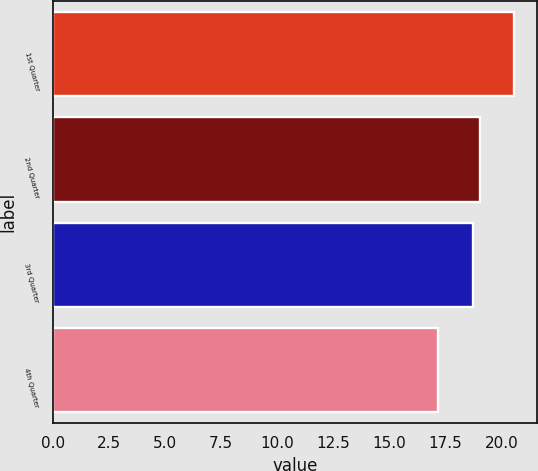Convert chart to OTSL. <chart><loc_0><loc_0><loc_500><loc_500><bar_chart><fcel>1st Quarter<fcel>2nd Quarter<fcel>3rd Quarter<fcel>4th Quarter<nl><fcel>20.56<fcel>19.06<fcel>18.72<fcel>17.18<nl></chart> 